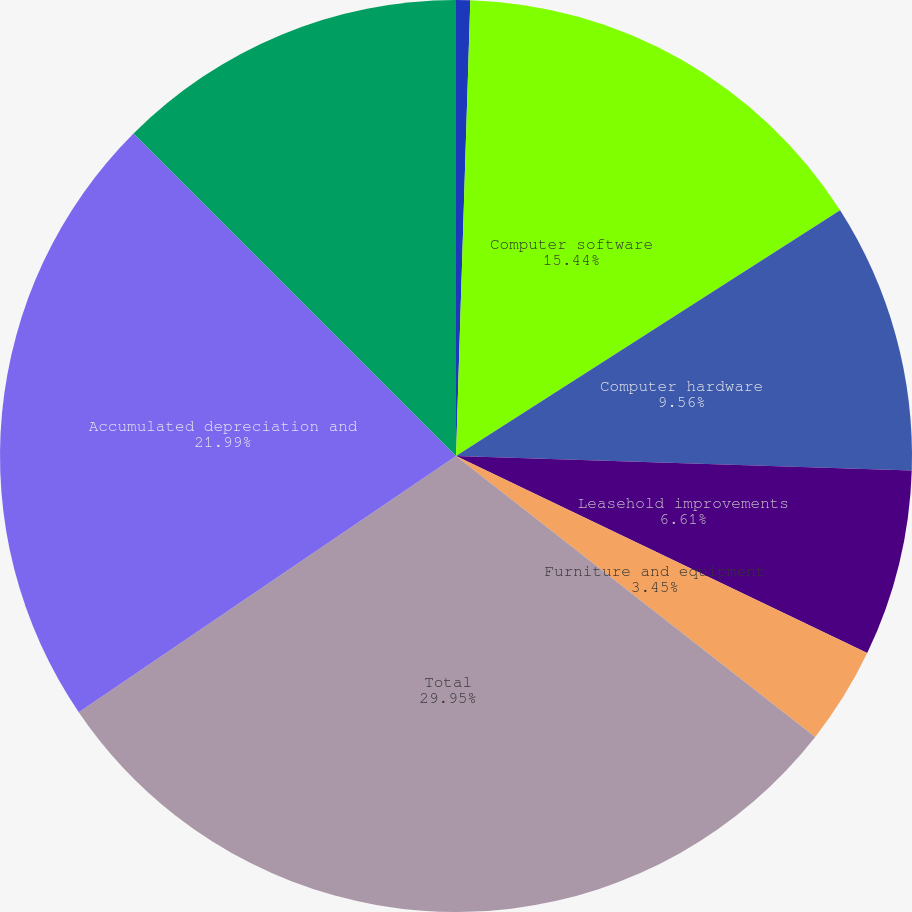Convert chart to OTSL. <chart><loc_0><loc_0><loc_500><loc_500><pie_chart><fcel>(Dollars in thousands)<fcel>Computer software<fcel>Computer hardware<fcel>Leasehold improvements<fcel>Furniture and equipment<fcel>Total<fcel>Accumulated depreciation and<fcel>Premises and equipment net<nl><fcel>0.5%<fcel>15.44%<fcel>9.56%<fcel>6.61%<fcel>3.45%<fcel>29.94%<fcel>21.99%<fcel>12.5%<nl></chart> 